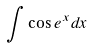Convert formula to latex. <formula><loc_0><loc_0><loc_500><loc_500>\int \cos e ^ { x } d x</formula> 